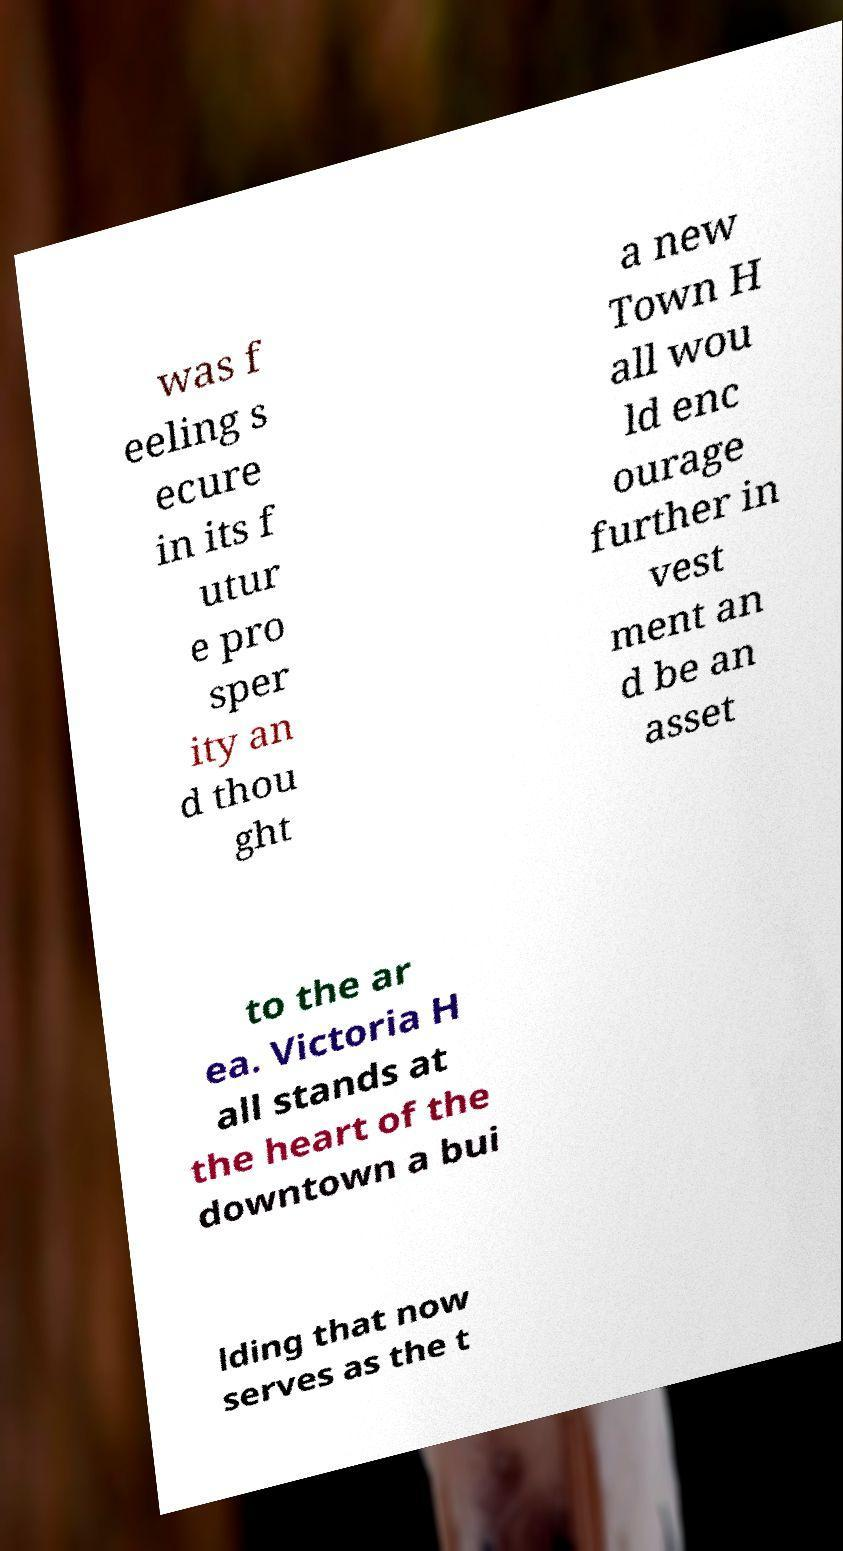Could you assist in decoding the text presented in this image and type it out clearly? was f eeling s ecure in its f utur e pro sper ity an d thou ght a new Town H all wou ld enc ourage further in vest ment an d be an asset to the ar ea. Victoria H all stands at the heart of the downtown a bui lding that now serves as the t 